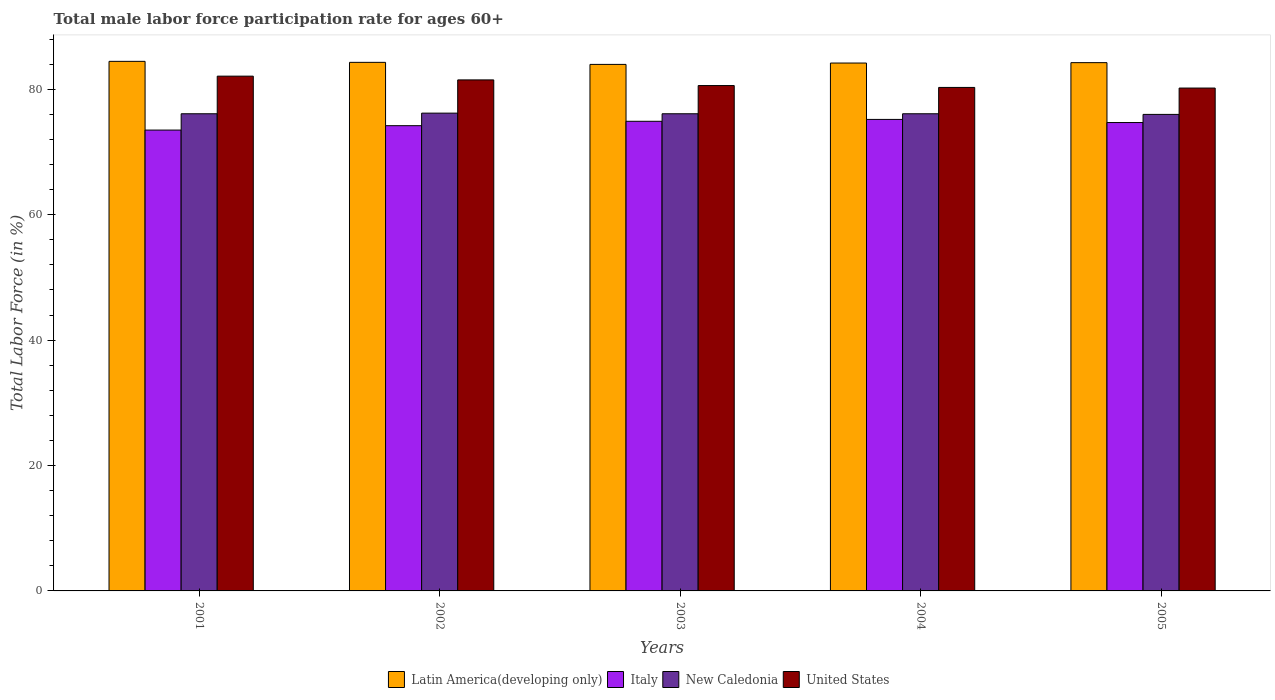How many different coloured bars are there?
Make the answer very short. 4. Are the number of bars per tick equal to the number of legend labels?
Ensure brevity in your answer.  Yes. Are the number of bars on each tick of the X-axis equal?
Offer a terse response. Yes. What is the male labor force participation rate in Latin America(developing only) in 2001?
Offer a terse response. 84.46. Across all years, what is the maximum male labor force participation rate in Latin America(developing only)?
Give a very brief answer. 84.46. Across all years, what is the minimum male labor force participation rate in New Caledonia?
Your answer should be very brief. 76. In which year was the male labor force participation rate in Italy maximum?
Provide a short and direct response. 2004. In which year was the male labor force participation rate in Italy minimum?
Provide a short and direct response. 2001. What is the total male labor force participation rate in New Caledonia in the graph?
Give a very brief answer. 380.5. What is the difference between the male labor force participation rate in Italy in 2002 and that in 2005?
Keep it short and to the point. -0.5. What is the difference between the male labor force participation rate in New Caledonia in 2005 and the male labor force participation rate in United States in 2003?
Ensure brevity in your answer.  -4.6. What is the average male labor force participation rate in Latin America(developing only) per year?
Ensure brevity in your answer.  84.23. In the year 2004, what is the difference between the male labor force participation rate in United States and male labor force participation rate in New Caledonia?
Provide a succinct answer. 4.2. In how many years, is the male labor force participation rate in Italy greater than 80 %?
Your answer should be very brief. 0. What is the ratio of the male labor force participation rate in Italy in 2003 to that in 2005?
Give a very brief answer. 1. Is the male labor force participation rate in New Caledonia in 2001 less than that in 2003?
Keep it short and to the point. No. What is the difference between the highest and the second highest male labor force participation rate in Latin America(developing only)?
Ensure brevity in your answer.  0.16. What is the difference between the highest and the lowest male labor force participation rate in United States?
Your answer should be very brief. 1.9. Is the sum of the male labor force participation rate in United States in 2002 and 2004 greater than the maximum male labor force participation rate in Italy across all years?
Provide a succinct answer. Yes. What does the 3rd bar from the left in 2003 represents?
Offer a terse response. New Caledonia. What does the 4th bar from the right in 2004 represents?
Give a very brief answer. Latin America(developing only). Is it the case that in every year, the sum of the male labor force participation rate in Latin America(developing only) and male labor force participation rate in New Caledonia is greater than the male labor force participation rate in Italy?
Give a very brief answer. Yes. What is the difference between two consecutive major ticks on the Y-axis?
Make the answer very short. 20. Are the values on the major ticks of Y-axis written in scientific E-notation?
Provide a succinct answer. No. How are the legend labels stacked?
Your answer should be compact. Horizontal. What is the title of the graph?
Your answer should be compact. Total male labor force participation rate for ages 60+. Does "Lebanon" appear as one of the legend labels in the graph?
Your answer should be compact. No. What is the Total Labor Force (in %) of Latin America(developing only) in 2001?
Give a very brief answer. 84.46. What is the Total Labor Force (in %) in Italy in 2001?
Make the answer very short. 73.5. What is the Total Labor Force (in %) in New Caledonia in 2001?
Your answer should be very brief. 76.1. What is the Total Labor Force (in %) of United States in 2001?
Ensure brevity in your answer.  82.1. What is the Total Labor Force (in %) of Latin America(developing only) in 2002?
Your response must be concise. 84.3. What is the Total Labor Force (in %) in Italy in 2002?
Your response must be concise. 74.2. What is the Total Labor Force (in %) of New Caledonia in 2002?
Keep it short and to the point. 76.2. What is the Total Labor Force (in %) of United States in 2002?
Offer a terse response. 81.5. What is the Total Labor Force (in %) of Latin America(developing only) in 2003?
Your response must be concise. 83.97. What is the Total Labor Force (in %) in Italy in 2003?
Offer a very short reply. 74.9. What is the Total Labor Force (in %) in New Caledonia in 2003?
Provide a short and direct response. 76.1. What is the Total Labor Force (in %) in United States in 2003?
Offer a terse response. 80.6. What is the Total Labor Force (in %) of Latin America(developing only) in 2004?
Your answer should be compact. 84.19. What is the Total Labor Force (in %) in Italy in 2004?
Give a very brief answer. 75.2. What is the Total Labor Force (in %) in New Caledonia in 2004?
Offer a very short reply. 76.1. What is the Total Labor Force (in %) in United States in 2004?
Your response must be concise. 80.3. What is the Total Labor Force (in %) of Latin America(developing only) in 2005?
Your answer should be very brief. 84.25. What is the Total Labor Force (in %) of Italy in 2005?
Ensure brevity in your answer.  74.7. What is the Total Labor Force (in %) in United States in 2005?
Your response must be concise. 80.2. Across all years, what is the maximum Total Labor Force (in %) in Latin America(developing only)?
Provide a short and direct response. 84.46. Across all years, what is the maximum Total Labor Force (in %) in Italy?
Provide a short and direct response. 75.2. Across all years, what is the maximum Total Labor Force (in %) of New Caledonia?
Give a very brief answer. 76.2. Across all years, what is the maximum Total Labor Force (in %) in United States?
Your answer should be very brief. 82.1. Across all years, what is the minimum Total Labor Force (in %) of Latin America(developing only)?
Make the answer very short. 83.97. Across all years, what is the minimum Total Labor Force (in %) of Italy?
Offer a terse response. 73.5. Across all years, what is the minimum Total Labor Force (in %) in New Caledonia?
Keep it short and to the point. 76. Across all years, what is the minimum Total Labor Force (in %) of United States?
Offer a very short reply. 80.2. What is the total Total Labor Force (in %) of Latin America(developing only) in the graph?
Make the answer very short. 421.17. What is the total Total Labor Force (in %) in Italy in the graph?
Keep it short and to the point. 372.5. What is the total Total Labor Force (in %) of New Caledonia in the graph?
Offer a terse response. 380.5. What is the total Total Labor Force (in %) in United States in the graph?
Provide a short and direct response. 404.7. What is the difference between the Total Labor Force (in %) in Latin America(developing only) in 2001 and that in 2002?
Offer a very short reply. 0.16. What is the difference between the Total Labor Force (in %) of New Caledonia in 2001 and that in 2002?
Give a very brief answer. -0.1. What is the difference between the Total Labor Force (in %) in United States in 2001 and that in 2002?
Your answer should be very brief. 0.6. What is the difference between the Total Labor Force (in %) in Latin America(developing only) in 2001 and that in 2003?
Your answer should be compact. 0.49. What is the difference between the Total Labor Force (in %) of Italy in 2001 and that in 2003?
Ensure brevity in your answer.  -1.4. What is the difference between the Total Labor Force (in %) of New Caledonia in 2001 and that in 2003?
Offer a very short reply. 0. What is the difference between the Total Labor Force (in %) in United States in 2001 and that in 2003?
Give a very brief answer. 1.5. What is the difference between the Total Labor Force (in %) in Latin America(developing only) in 2001 and that in 2004?
Provide a succinct answer. 0.27. What is the difference between the Total Labor Force (in %) of United States in 2001 and that in 2004?
Provide a succinct answer. 1.8. What is the difference between the Total Labor Force (in %) in Latin America(developing only) in 2001 and that in 2005?
Your answer should be very brief. 0.21. What is the difference between the Total Labor Force (in %) of New Caledonia in 2001 and that in 2005?
Your response must be concise. 0.1. What is the difference between the Total Labor Force (in %) of Latin America(developing only) in 2002 and that in 2003?
Make the answer very short. 0.33. What is the difference between the Total Labor Force (in %) in Italy in 2002 and that in 2003?
Provide a succinct answer. -0.7. What is the difference between the Total Labor Force (in %) in United States in 2002 and that in 2003?
Offer a terse response. 0.9. What is the difference between the Total Labor Force (in %) of Latin America(developing only) in 2002 and that in 2004?
Offer a very short reply. 0.11. What is the difference between the Total Labor Force (in %) of Italy in 2002 and that in 2004?
Make the answer very short. -1. What is the difference between the Total Labor Force (in %) of United States in 2002 and that in 2004?
Keep it short and to the point. 1.2. What is the difference between the Total Labor Force (in %) of Latin America(developing only) in 2002 and that in 2005?
Your answer should be compact. 0.05. What is the difference between the Total Labor Force (in %) of New Caledonia in 2002 and that in 2005?
Your answer should be very brief. 0.2. What is the difference between the Total Labor Force (in %) of United States in 2002 and that in 2005?
Your response must be concise. 1.3. What is the difference between the Total Labor Force (in %) in Latin America(developing only) in 2003 and that in 2004?
Make the answer very short. -0.22. What is the difference between the Total Labor Force (in %) of United States in 2003 and that in 2004?
Your answer should be compact. 0.3. What is the difference between the Total Labor Force (in %) in Latin America(developing only) in 2003 and that in 2005?
Provide a succinct answer. -0.28. What is the difference between the Total Labor Force (in %) of United States in 2003 and that in 2005?
Provide a succinct answer. 0.4. What is the difference between the Total Labor Force (in %) in Latin America(developing only) in 2004 and that in 2005?
Provide a succinct answer. -0.06. What is the difference between the Total Labor Force (in %) of Italy in 2004 and that in 2005?
Provide a short and direct response. 0.5. What is the difference between the Total Labor Force (in %) in New Caledonia in 2004 and that in 2005?
Provide a short and direct response. 0.1. What is the difference between the Total Labor Force (in %) of Latin America(developing only) in 2001 and the Total Labor Force (in %) of Italy in 2002?
Provide a succinct answer. 10.26. What is the difference between the Total Labor Force (in %) of Latin America(developing only) in 2001 and the Total Labor Force (in %) of New Caledonia in 2002?
Give a very brief answer. 8.26. What is the difference between the Total Labor Force (in %) in Latin America(developing only) in 2001 and the Total Labor Force (in %) in United States in 2002?
Provide a succinct answer. 2.96. What is the difference between the Total Labor Force (in %) of Italy in 2001 and the Total Labor Force (in %) of United States in 2002?
Make the answer very short. -8. What is the difference between the Total Labor Force (in %) in Latin America(developing only) in 2001 and the Total Labor Force (in %) in Italy in 2003?
Your answer should be very brief. 9.56. What is the difference between the Total Labor Force (in %) of Latin America(developing only) in 2001 and the Total Labor Force (in %) of New Caledonia in 2003?
Offer a terse response. 8.36. What is the difference between the Total Labor Force (in %) in Latin America(developing only) in 2001 and the Total Labor Force (in %) in United States in 2003?
Provide a short and direct response. 3.86. What is the difference between the Total Labor Force (in %) of Italy in 2001 and the Total Labor Force (in %) of New Caledonia in 2003?
Offer a terse response. -2.6. What is the difference between the Total Labor Force (in %) of Italy in 2001 and the Total Labor Force (in %) of United States in 2003?
Your answer should be compact. -7.1. What is the difference between the Total Labor Force (in %) of New Caledonia in 2001 and the Total Labor Force (in %) of United States in 2003?
Ensure brevity in your answer.  -4.5. What is the difference between the Total Labor Force (in %) of Latin America(developing only) in 2001 and the Total Labor Force (in %) of Italy in 2004?
Provide a succinct answer. 9.26. What is the difference between the Total Labor Force (in %) of Latin America(developing only) in 2001 and the Total Labor Force (in %) of New Caledonia in 2004?
Give a very brief answer. 8.36. What is the difference between the Total Labor Force (in %) in Latin America(developing only) in 2001 and the Total Labor Force (in %) in United States in 2004?
Keep it short and to the point. 4.16. What is the difference between the Total Labor Force (in %) of Italy in 2001 and the Total Labor Force (in %) of New Caledonia in 2004?
Offer a very short reply. -2.6. What is the difference between the Total Labor Force (in %) of Italy in 2001 and the Total Labor Force (in %) of United States in 2004?
Keep it short and to the point. -6.8. What is the difference between the Total Labor Force (in %) in New Caledonia in 2001 and the Total Labor Force (in %) in United States in 2004?
Make the answer very short. -4.2. What is the difference between the Total Labor Force (in %) of Latin America(developing only) in 2001 and the Total Labor Force (in %) of Italy in 2005?
Your response must be concise. 9.76. What is the difference between the Total Labor Force (in %) in Latin America(developing only) in 2001 and the Total Labor Force (in %) in New Caledonia in 2005?
Provide a short and direct response. 8.46. What is the difference between the Total Labor Force (in %) of Latin America(developing only) in 2001 and the Total Labor Force (in %) of United States in 2005?
Offer a terse response. 4.26. What is the difference between the Total Labor Force (in %) of Italy in 2001 and the Total Labor Force (in %) of United States in 2005?
Your response must be concise. -6.7. What is the difference between the Total Labor Force (in %) in New Caledonia in 2001 and the Total Labor Force (in %) in United States in 2005?
Ensure brevity in your answer.  -4.1. What is the difference between the Total Labor Force (in %) in Latin America(developing only) in 2002 and the Total Labor Force (in %) in Italy in 2003?
Your answer should be very brief. 9.4. What is the difference between the Total Labor Force (in %) of Latin America(developing only) in 2002 and the Total Labor Force (in %) of New Caledonia in 2003?
Provide a short and direct response. 8.2. What is the difference between the Total Labor Force (in %) in Latin America(developing only) in 2002 and the Total Labor Force (in %) in United States in 2003?
Keep it short and to the point. 3.7. What is the difference between the Total Labor Force (in %) in New Caledonia in 2002 and the Total Labor Force (in %) in United States in 2003?
Provide a short and direct response. -4.4. What is the difference between the Total Labor Force (in %) in Latin America(developing only) in 2002 and the Total Labor Force (in %) in Italy in 2004?
Offer a very short reply. 9.1. What is the difference between the Total Labor Force (in %) in Latin America(developing only) in 2002 and the Total Labor Force (in %) in New Caledonia in 2004?
Your response must be concise. 8.2. What is the difference between the Total Labor Force (in %) of Latin America(developing only) in 2002 and the Total Labor Force (in %) of United States in 2004?
Provide a short and direct response. 4. What is the difference between the Total Labor Force (in %) in Italy in 2002 and the Total Labor Force (in %) in New Caledonia in 2004?
Your answer should be very brief. -1.9. What is the difference between the Total Labor Force (in %) in New Caledonia in 2002 and the Total Labor Force (in %) in United States in 2004?
Provide a short and direct response. -4.1. What is the difference between the Total Labor Force (in %) of Latin America(developing only) in 2002 and the Total Labor Force (in %) of Italy in 2005?
Ensure brevity in your answer.  9.6. What is the difference between the Total Labor Force (in %) in Latin America(developing only) in 2002 and the Total Labor Force (in %) in New Caledonia in 2005?
Your response must be concise. 8.3. What is the difference between the Total Labor Force (in %) in Latin America(developing only) in 2002 and the Total Labor Force (in %) in United States in 2005?
Provide a succinct answer. 4.1. What is the difference between the Total Labor Force (in %) in Italy in 2002 and the Total Labor Force (in %) in United States in 2005?
Give a very brief answer. -6. What is the difference between the Total Labor Force (in %) of New Caledonia in 2002 and the Total Labor Force (in %) of United States in 2005?
Provide a succinct answer. -4. What is the difference between the Total Labor Force (in %) in Latin America(developing only) in 2003 and the Total Labor Force (in %) in Italy in 2004?
Your response must be concise. 8.77. What is the difference between the Total Labor Force (in %) in Latin America(developing only) in 2003 and the Total Labor Force (in %) in New Caledonia in 2004?
Ensure brevity in your answer.  7.87. What is the difference between the Total Labor Force (in %) of Latin America(developing only) in 2003 and the Total Labor Force (in %) of United States in 2004?
Offer a terse response. 3.67. What is the difference between the Total Labor Force (in %) in Latin America(developing only) in 2003 and the Total Labor Force (in %) in Italy in 2005?
Your response must be concise. 9.27. What is the difference between the Total Labor Force (in %) of Latin America(developing only) in 2003 and the Total Labor Force (in %) of New Caledonia in 2005?
Give a very brief answer. 7.97. What is the difference between the Total Labor Force (in %) in Latin America(developing only) in 2003 and the Total Labor Force (in %) in United States in 2005?
Your answer should be compact. 3.77. What is the difference between the Total Labor Force (in %) of Italy in 2003 and the Total Labor Force (in %) of New Caledonia in 2005?
Offer a very short reply. -1.1. What is the difference between the Total Labor Force (in %) of Italy in 2003 and the Total Labor Force (in %) of United States in 2005?
Offer a very short reply. -5.3. What is the difference between the Total Labor Force (in %) of New Caledonia in 2003 and the Total Labor Force (in %) of United States in 2005?
Give a very brief answer. -4.1. What is the difference between the Total Labor Force (in %) in Latin America(developing only) in 2004 and the Total Labor Force (in %) in Italy in 2005?
Offer a very short reply. 9.49. What is the difference between the Total Labor Force (in %) in Latin America(developing only) in 2004 and the Total Labor Force (in %) in New Caledonia in 2005?
Ensure brevity in your answer.  8.19. What is the difference between the Total Labor Force (in %) in Latin America(developing only) in 2004 and the Total Labor Force (in %) in United States in 2005?
Ensure brevity in your answer.  3.99. What is the difference between the Total Labor Force (in %) of Italy in 2004 and the Total Labor Force (in %) of New Caledonia in 2005?
Offer a very short reply. -0.8. What is the difference between the Total Labor Force (in %) in Italy in 2004 and the Total Labor Force (in %) in United States in 2005?
Provide a short and direct response. -5. What is the average Total Labor Force (in %) of Latin America(developing only) per year?
Offer a very short reply. 84.23. What is the average Total Labor Force (in %) in Italy per year?
Give a very brief answer. 74.5. What is the average Total Labor Force (in %) of New Caledonia per year?
Provide a succinct answer. 76.1. What is the average Total Labor Force (in %) in United States per year?
Offer a very short reply. 80.94. In the year 2001, what is the difference between the Total Labor Force (in %) in Latin America(developing only) and Total Labor Force (in %) in Italy?
Your answer should be very brief. 10.96. In the year 2001, what is the difference between the Total Labor Force (in %) in Latin America(developing only) and Total Labor Force (in %) in New Caledonia?
Give a very brief answer. 8.36. In the year 2001, what is the difference between the Total Labor Force (in %) of Latin America(developing only) and Total Labor Force (in %) of United States?
Offer a very short reply. 2.36. In the year 2001, what is the difference between the Total Labor Force (in %) in Italy and Total Labor Force (in %) in New Caledonia?
Provide a succinct answer. -2.6. In the year 2002, what is the difference between the Total Labor Force (in %) of Latin America(developing only) and Total Labor Force (in %) of Italy?
Your answer should be very brief. 10.1. In the year 2002, what is the difference between the Total Labor Force (in %) of Latin America(developing only) and Total Labor Force (in %) of New Caledonia?
Provide a succinct answer. 8.1. In the year 2002, what is the difference between the Total Labor Force (in %) of Latin America(developing only) and Total Labor Force (in %) of United States?
Your answer should be compact. 2.8. In the year 2002, what is the difference between the Total Labor Force (in %) of Italy and Total Labor Force (in %) of United States?
Your response must be concise. -7.3. In the year 2002, what is the difference between the Total Labor Force (in %) of New Caledonia and Total Labor Force (in %) of United States?
Provide a short and direct response. -5.3. In the year 2003, what is the difference between the Total Labor Force (in %) of Latin America(developing only) and Total Labor Force (in %) of Italy?
Provide a short and direct response. 9.07. In the year 2003, what is the difference between the Total Labor Force (in %) of Latin America(developing only) and Total Labor Force (in %) of New Caledonia?
Your answer should be very brief. 7.87. In the year 2003, what is the difference between the Total Labor Force (in %) in Latin America(developing only) and Total Labor Force (in %) in United States?
Offer a very short reply. 3.37. In the year 2003, what is the difference between the Total Labor Force (in %) in Italy and Total Labor Force (in %) in United States?
Your answer should be very brief. -5.7. In the year 2003, what is the difference between the Total Labor Force (in %) of New Caledonia and Total Labor Force (in %) of United States?
Provide a succinct answer. -4.5. In the year 2004, what is the difference between the Total Labor Force (in %) of Latin America(developing only) and Total Labor Force (in %) of Italy?
Keep it short and to the point. 8.99. In the year 2004, what is the difference between the Total Labor Force (in %) of Latin America(developing only) and Total Labor Force (in %) of New Caledonia?
Make the answer very short. 8.09. In the year 2004, what is the difference between the Total Labor Force (in %) in Latin America(developing only) and Total Labor Force (in %) in United States?
Your answer should be very brief. 3.89. In the year 2004, what is the difference between the Total Labor Force (in %) of Italy and Total Labor Force (in %) of New Caledonia?
Your answer should be very brief. -0.9. In the year 2004, what is the difference between the Total Labor Force (in %) in Italy and Total Labor Force (in %) in United States?
Ensure brevity in your answer.  -5.1. In the year 2004, what is the difference between the Total Labor Force (in %) of New Caledonia and Total Labor Force (in %) of United States?
Provide a short and direct response. -4.2. In the year 2005, what is the difference between the Total Labor Force (in %) in Latin America(developing only) and Total Labor Force (in %) in Italy?
Make the answer very short. 9.55. In the year 2005, what is the difference between the Total Labor Force (in %) of Latin America(developing only) and Total Labor Force (in %) of New Caledonia?
Your answer should be very brief. 8.25. In the year 2005, what is the difference between the Total Labor Force (in %) of Latin America(developing only) and Total Labor Force (in %) of United States?
Provide a succinct answer. 4.05. What is the ratio of the Total Labor Force (in %) of Latin America(developing only) in 2001 to that in 2002?
Provide a succinct answer. 1. What is the ratio of the Total Labor Force (in %) of Italy in 2001 to that in 2002?
Ensure brevity in your answer.  0.99. What is the ratio of the Total Labor Force (in %) in New Caledonia in 2001 to that in 2002?
Provide a short and direct response. 1. What is the ratio of the Total Labor Force (in %) in United States in 2001 to that in 2002?
Your response must be concise. 1.01. What is the ratio of the Total Labor Force (in %) of Latin America(developing only) in 2001 to that in 2003?
Provide a short and direct response. 1.01. What is the ratio of the Total Labor Force (in %) of Italy in 2001 to that in 2003?
Ensure brevity in your answer.  0.98. What is the ratio of the Total Labor Force (in %) in United States in 2001 to that in 2003?
Your answer should be compact. 1.02. What is the ratio of the Total Labor Force (in %) of Latin America(developing only) in 2001 to that in 2004?
Offer a terse response. 1. What is the ratio of the Total Labor Force (in %) in Italy in 2001 to that in 2004?
Provide a short and direct response. 0.98. What is the ratio of the Total Labor Force (in %) of United States in 2001 to that in 2004?
Make the answer very short. 1.02. What is the ratio of the Total Labor Force (in %) in Italy in 2001 to that in 2005?
Provide a short and direct response. 0.98. What is the ratio of the Total Labor Force (in %) of United States in 2001 to that in 2005?
Your answer should be compact. 1.02. What is the ratio of the Total Labor Force (in %) in United States in 2002 to that in 2003?
Give a very brief answer. 1.01. What is the ratio of the Total Labor Force (in %) of Italy in 2002 to that in 2004?
Offer a very short reply. 0.99. What is the ratio of the Total Labor Force (in %) in New Caledonia in 2002 to that in 2004?
Ensure brevity in your answer.  1. What is the ratio of the Total Labor Force (in %) in United States in 2002 to that in 2004?
Offer a terse response. 1.01. What is the ratio of the Total Labor Force (in %) in Italy in 2002 to that in 2005?
Keep it short and to the point. 0.99. What is the ratio of the Total Labor Force (in %) in New Caledonia in 2002 to that in 2005?
Provide a succinct answer. 1. What is the ratio of the Total Labor Force (in %) in United States in 2002 to that in 2005?
Ensure brevity in your answer.  1.02. What is the ratio of the Total Labor Force (in %) of Latin America(developing only) in 2003 to that in 2005?
Ensure brevity in your answer.  1. What is the ratio of the Total Labor Force (in %) of Italy in 2003 to that in 2005?
Make the answer very short. 1. What is the ratio of the Total Labor Force (in %) of New Caledonia in 2003 to that in 2005?
Give a very brief answer. 1. What is the ratio of the Total Labor Force (in %) of Latin America(developing only) in 2004 to that in 2005?
Keep it short and to the point. 1. What is the ratio of the Total Labor Force (in %) of Italy in 2004 to that in 2005?
Keep it short and to the point. 1.01. What is the ratio of the Total Labor Force (in %) in New Caledonia in 2004 to that in 2005?
Provide a short and direct response. 1. What is the difference between the highest and the second highest Total Labor Force (in %) of Latin America(developing only)?
Provide a succinct answer. 0.16. What is the difference between the highest and the second highest Total Labor Force (in %) in Italy?
Offer a terse response. 0.3. What is the difference between the highest and the lowest Total Labor Force (in %) in Latin America(developing only)?
Offer a very short reply. 0.49. What is the difference between the highest and the lowest Total Labor Force (in %) of New Caledonia?
Provide a short and direct response. 0.2. 